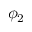Convert formula to latex. <formula><loc_0><loc_0><loc_500><loc_500>\phi _ { 2 }</formula> 